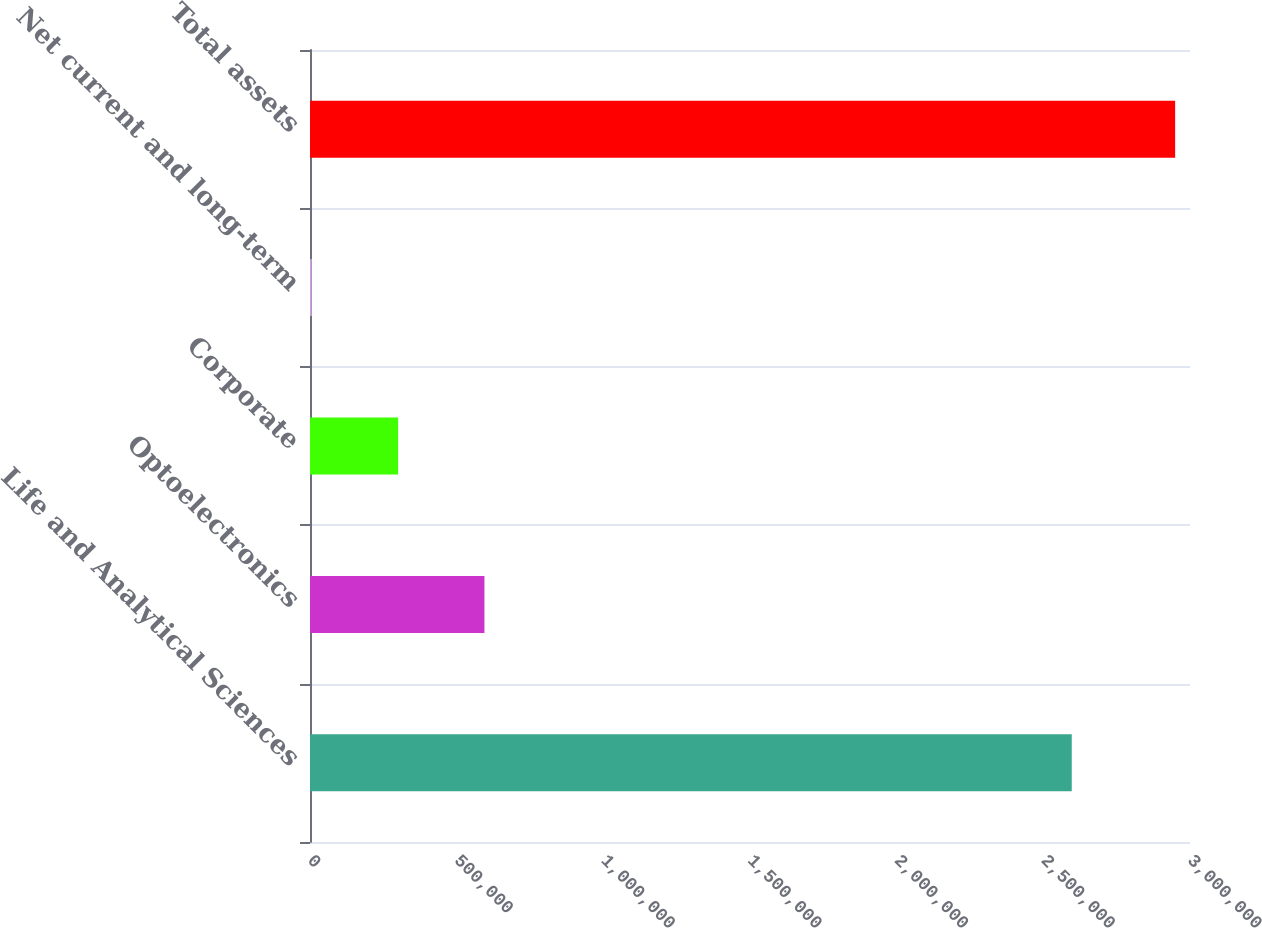<chart> <loc_0><loc_0><loc_500><loc_500><bar_chart><fcel>Life and Analytical Sciences<fcel>Optoelectronics<fcel>Corporate<fcel>Net current and long-term<fcel>Total assets<nl><fcel>2.59687e+06<fcel>594682<fcel>300350<fcel>6018<fcel>2.94934e+06<nl></chart> 